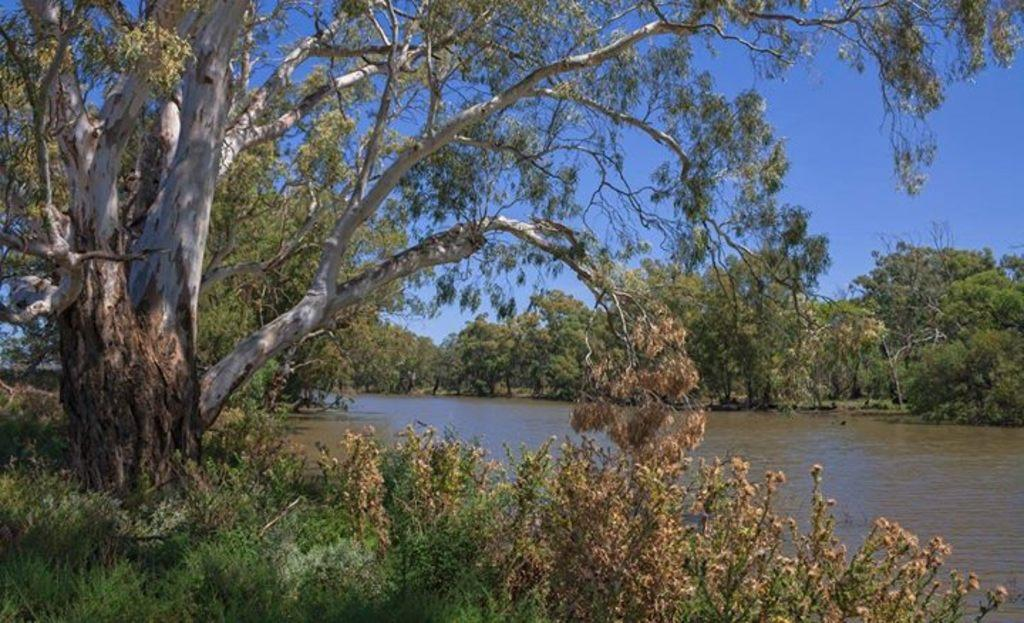What is the primary element visible in the image? There is water in the image. What type of vegetation can be seen in the image? There are trees and plants in the image. What part of the natural environment is visible in the background of the image? The sky is visible in the background of the image. Can you see a cat pushing an eggnog cart in the image? No, there is no cat or eggnog cart present in the image. 